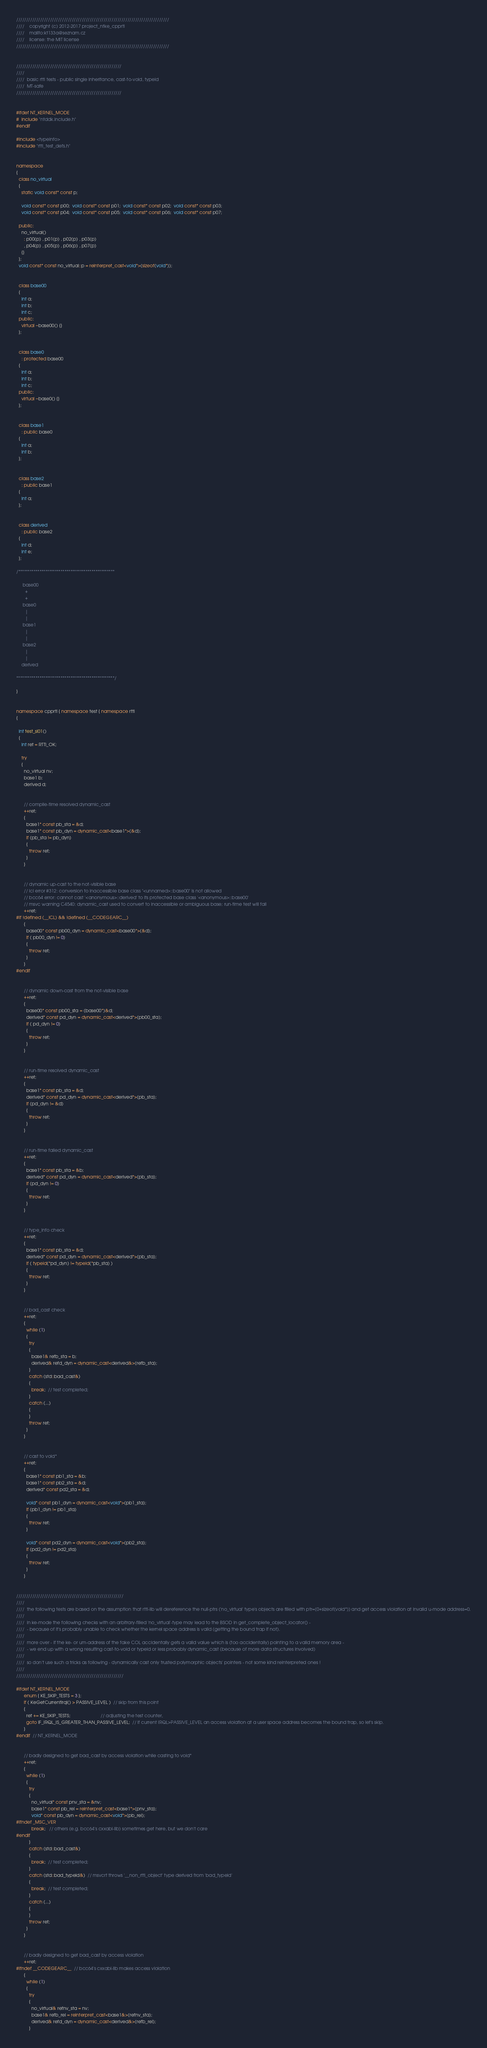<code> <loc_0><loc_0><loc_500><loc_500><_C++_>/////////////////////////////////////////////////////////////////////////////
////    copyright (c) 2012-2017 project_ntke_cpprtl
////    mailto:kt133a@seznam.cz
////    license: the MIT license
/////////////////////////////////////////////////////////////////////////////


/////////////////////////////////////////////////////
////
////  basic rtti tests - public single inheritance, cast-to-void, typeid
////  MT-safe
/////////////////////////////////////////////////////


#ifdef NT_KERNEL_MODE
#  include "ntddk.include.h"
#endif

#include <typeinfo>
#include "rtti_test_defs.h"


namespace
{
  class no_virtual
  {
    static void const* const p;

    void const* const p00;  void const* const p01;  void const* const p02;  void const* const p03;
    void const* const p04;  void const* const p05;  void const* const p06;  void const* const p07;

  public:
    no_virtual()
      : p00(p) , p01(p) , p02(p) , p03(p)
      , p04(p) , p05(p) , p06(p) , p07(p)
    {}
  };
  void const* const no_virtual::p = reinterpret_cast<void*>(sizeof(void*));


  class base00
  {
    int a;
    int b;
    int c;
  public:
    virtual ~base00() {}
  };


  class base0
    : protected base00
  {
    int a;
    int b;
    int c;
  public:
    virtual ~base0() {}
  };


  class base1
    : public base0
  {
    int a;
    int b;
  };


  class base2
    : public base1
  {
    int a;
  };


  class derived
    : public base2
  {
    int d;
    int e;
  };

/**************************************************

     base00
       +
       +
     base0
       |
       |
     base1
       |
       |
     base2
       |
       |
    derived

***************************************************/

}


namespace cpprtl { namespace test { namespace rtti
{

  int test_si01()
  {
    int ret = RTTI_OK;

    try
    {
      no_virtual nv;
      base1 b;
      derived d;


      // compile-time resolved dynamic_cast
      ++ret;
      {
        base1* const pb_sta = &d;
        base1* const pb_dyn = dynamic_cast<base1*>(&d);
        if (pb_sta != pb_dyn)
        {
          throw ret;
        }
      }


      // dynamic up-cast to the not-visible base
      // icl error #312: conversion to inaccessible base class "<unnamed>::base00" is not allowed
      // bcc64 error: cannot cast '<anonymous>::derived' to its protected base class '<anonymous>::base00'
      // msvc warning C4540: dynamic_cast used to convert to inaccessible or ambiguous base; run-time test will fail
      ++ret;
#if !defined (__ICL) && !defined (__CODEGEARC__)
      {
        base00* const pb00_dyn = dynamic_cast<base00*>(&d);
        if ( pb00_dyn != 0)
        {
          throw ret;
        }
      }
#endif


      // dynamic down-cast from the not-visible base
      ++ret;
      {
        base00* const pb00_sta = (base00*)&d;
        derived* const pd_dyn = dynamic_cast<derived*>(pb00_sta);
        if ( pd_dyn != 0)
        {
          throw ret;
        }
      }


      // run-time resolved dynamic_cast
      ++ret;
      {
        base1* const pb_sta = &d;
        derived* const pd_dyn = dynamic_cast<derived*>(pb_sta);
        if (pd_dyn != &d)
        {
          throw ret;
        }
      }


      // run-time failed dynamic_cast
      ++ret;
      {
        base1* const pb_sta = &b;
        derived* const pd_dyn = dynamic_cast<derived*>(pb_sta);
        if (pd_dyn != 0)
        {
          throw ret;
        }
      }


      // type_info check
      ++ret;
      {
        base1* const pb_sta = &d;
        derived* const pd_dyn = dynamic_cast<derived*>(pb_sta);
        if ( typeid(*pd_dyn) != typeid(*pb_sta) )
        {
          throw ret;
        }
      }


      // bad_cast check
      ++ret;
      {
        while (1)
        {
          try
          {
            base1& refb_sta = b;
            derived& refd_dyn = dynamic_cast<derived&>(refb_sta);
          }
          catch (std::bad_cast&)
          {
            break;  // test completed;
          }
          catch (...)
          {
          }
          throw ret;
        }
      }


      // cast to void*
      ++ret;
      {
        base1* const pb1_sta = &b;
        base1* const pb2_sta = &d;
        derived* const pd2_sta = &d;

        void* const pb1_dyn = dynamic_cast<void*>(pb1_sta);
        if (pb1_dyn != pb1_sta)
        {
          throw ret;
        }

        void* const pd2_dyn = dynamic_cast<void*>(pb2_sta);
        if (pd2_dyn != pd2_sta)
        {
          throw ret;
        }
      }


//////////////////////////////////////////////////////
////
////  the following tests are based on the assumption that rtti-lib will dereference the null-ptrs ('no_virtual' type's objects are filled with ptr=(0+sizeof(void*)) and get access violation at invalid u-mode address=0.
////
////  in ke-mode the following checks with an arbitrary-filled 'no_virtual'-type may lead to the BSOD in get_complete_object_locator() -
////  - because of it's probably unable to check whether the kernel space address is valid (getting the bound trap if not).
////
////  more over - if the ke- or um-address of the fake COL accidentally gets a valid value which is (too accidentally) pointing to a valid memory area -
////  - we end up with a wrong resulting cast-to-void or typeid or less probably dynamic_cast (because of more data structures involved)
////
////  so don't use such a tricks as following - dynamically cast only trusted polymorphic objects' pointers - not some kind reinterpreted ones !
////
//////////////////////////////////////////////////////

#ifdef NT_KERNEL_MODE
      enum { KE_SKIP_TESTS = 3 };
      if ( KeGetCurrentIrql() > PASSIVE_LEVEL )  // skip from this point
      {
        ret += KE_SKIP_TESTS;                        // adjusting the test counter,
        goto IF_IRQL_IS_GREATER_THAN_PASSIVE_LEVEL;  // if current IRQL>PASSIVE_LEVEL an access violation at a user space address becomes the bound trap, so let's skip.
      }
#endif  // NT_KERNEL_MODE


      // badly designed to get bad_cast by access violation while casting to void*
      ++ret;
      {
        while (1)
        {
          try
          {
            no_virtual* const pnv_sta = &nv;
            base1* const pb_rei = reinterpret_cast<base1*>(pnv_sta);
            void* const pb_dyn = dynamic_cast<void*>(pb_rei);
#ifndef _MSC_VER
            break;   // others (e.g. bcc64's cxxabi-lib) sometimes get here, but we don't care
#endif
          }
          catch (std::bad_cast&)
          {
            break;  // test completed;
          }                            
          catch (std::bad_typeid&)  // msvcrt throws '__non_rtti_object' type derived from 'bad_typeid'
          {
            break;  // test completed;
          }
          catch (...)
          {
          }
          throw ret;
        }
      }


      // badly designed to get bad_cast by access violation
      ++ret;
#ifndef __CODEGEARC__  // bcc64's cxxabi-lib makes access violation
      {
        while (1)
        {
          try
          {
            no_virtual& refnv_sta = nv;
            base1& refb_rei = reinterpret_cast<base1&>(refnv_sta);
            derived& refd_dyn = dynamic_cast<derived&>(refb_rei);
          }</code> 